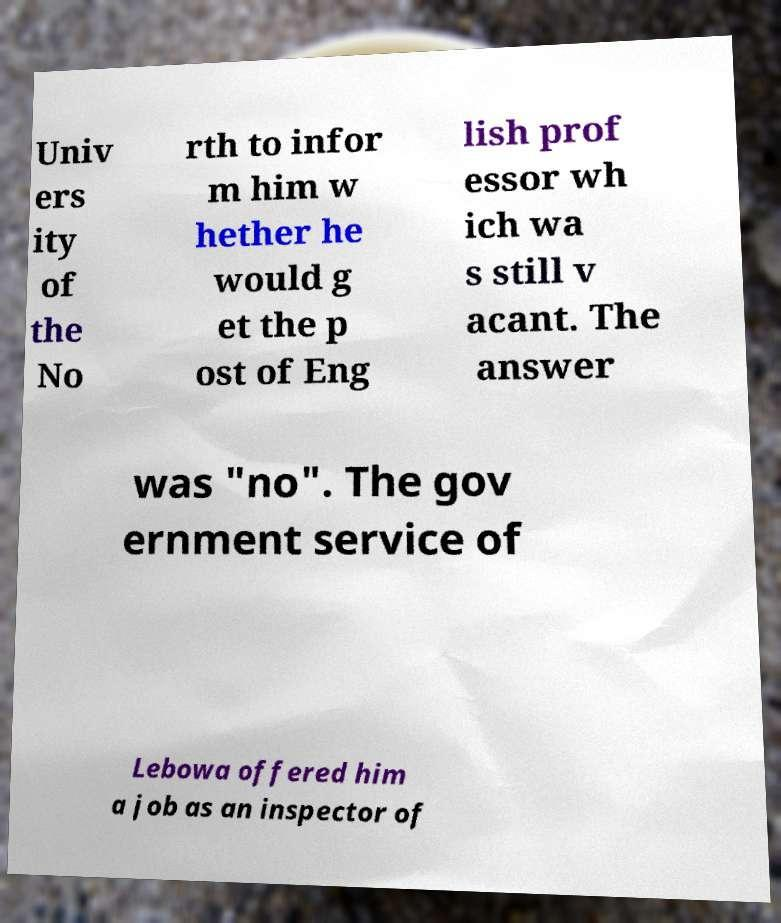What messages or text are displayed in this image? I need them in a readable, typed format. Univ ers ity of the No rth to infor m him w hether he would g et the p ost of Eng lish prof essor wh ich wa s still v acant. The answer was "no". The gov ernment service of Lebowa offered him a job as an inspector of 